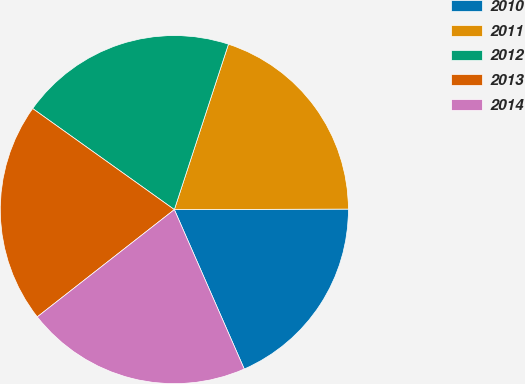Convert chart to OTSL. <chart><loc_0><loc_0><loc_500><loc_500><pie_chart><fcel>2010<fcel>2011<fcel>2012<fcel>2013<fcel>2014<nl><fcel>18.47%<fcel>19.92%<fcel>20.17%<fcel>20.43%<fcel>21.01%<nl></chart> 